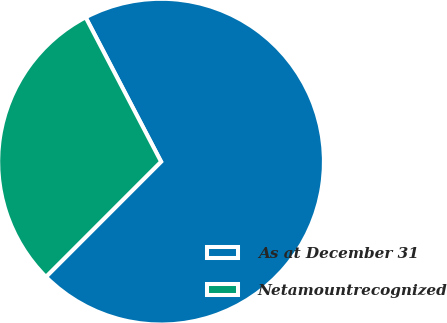Convert chart to OTSL. <chart><loc_0><loc_0><loc_500><loc_500><pie_chart><fcel>As at December 31<fcel>Netamountrecognized<nl><fcel>70.16%<fcel>29.84%<nl></chart> 